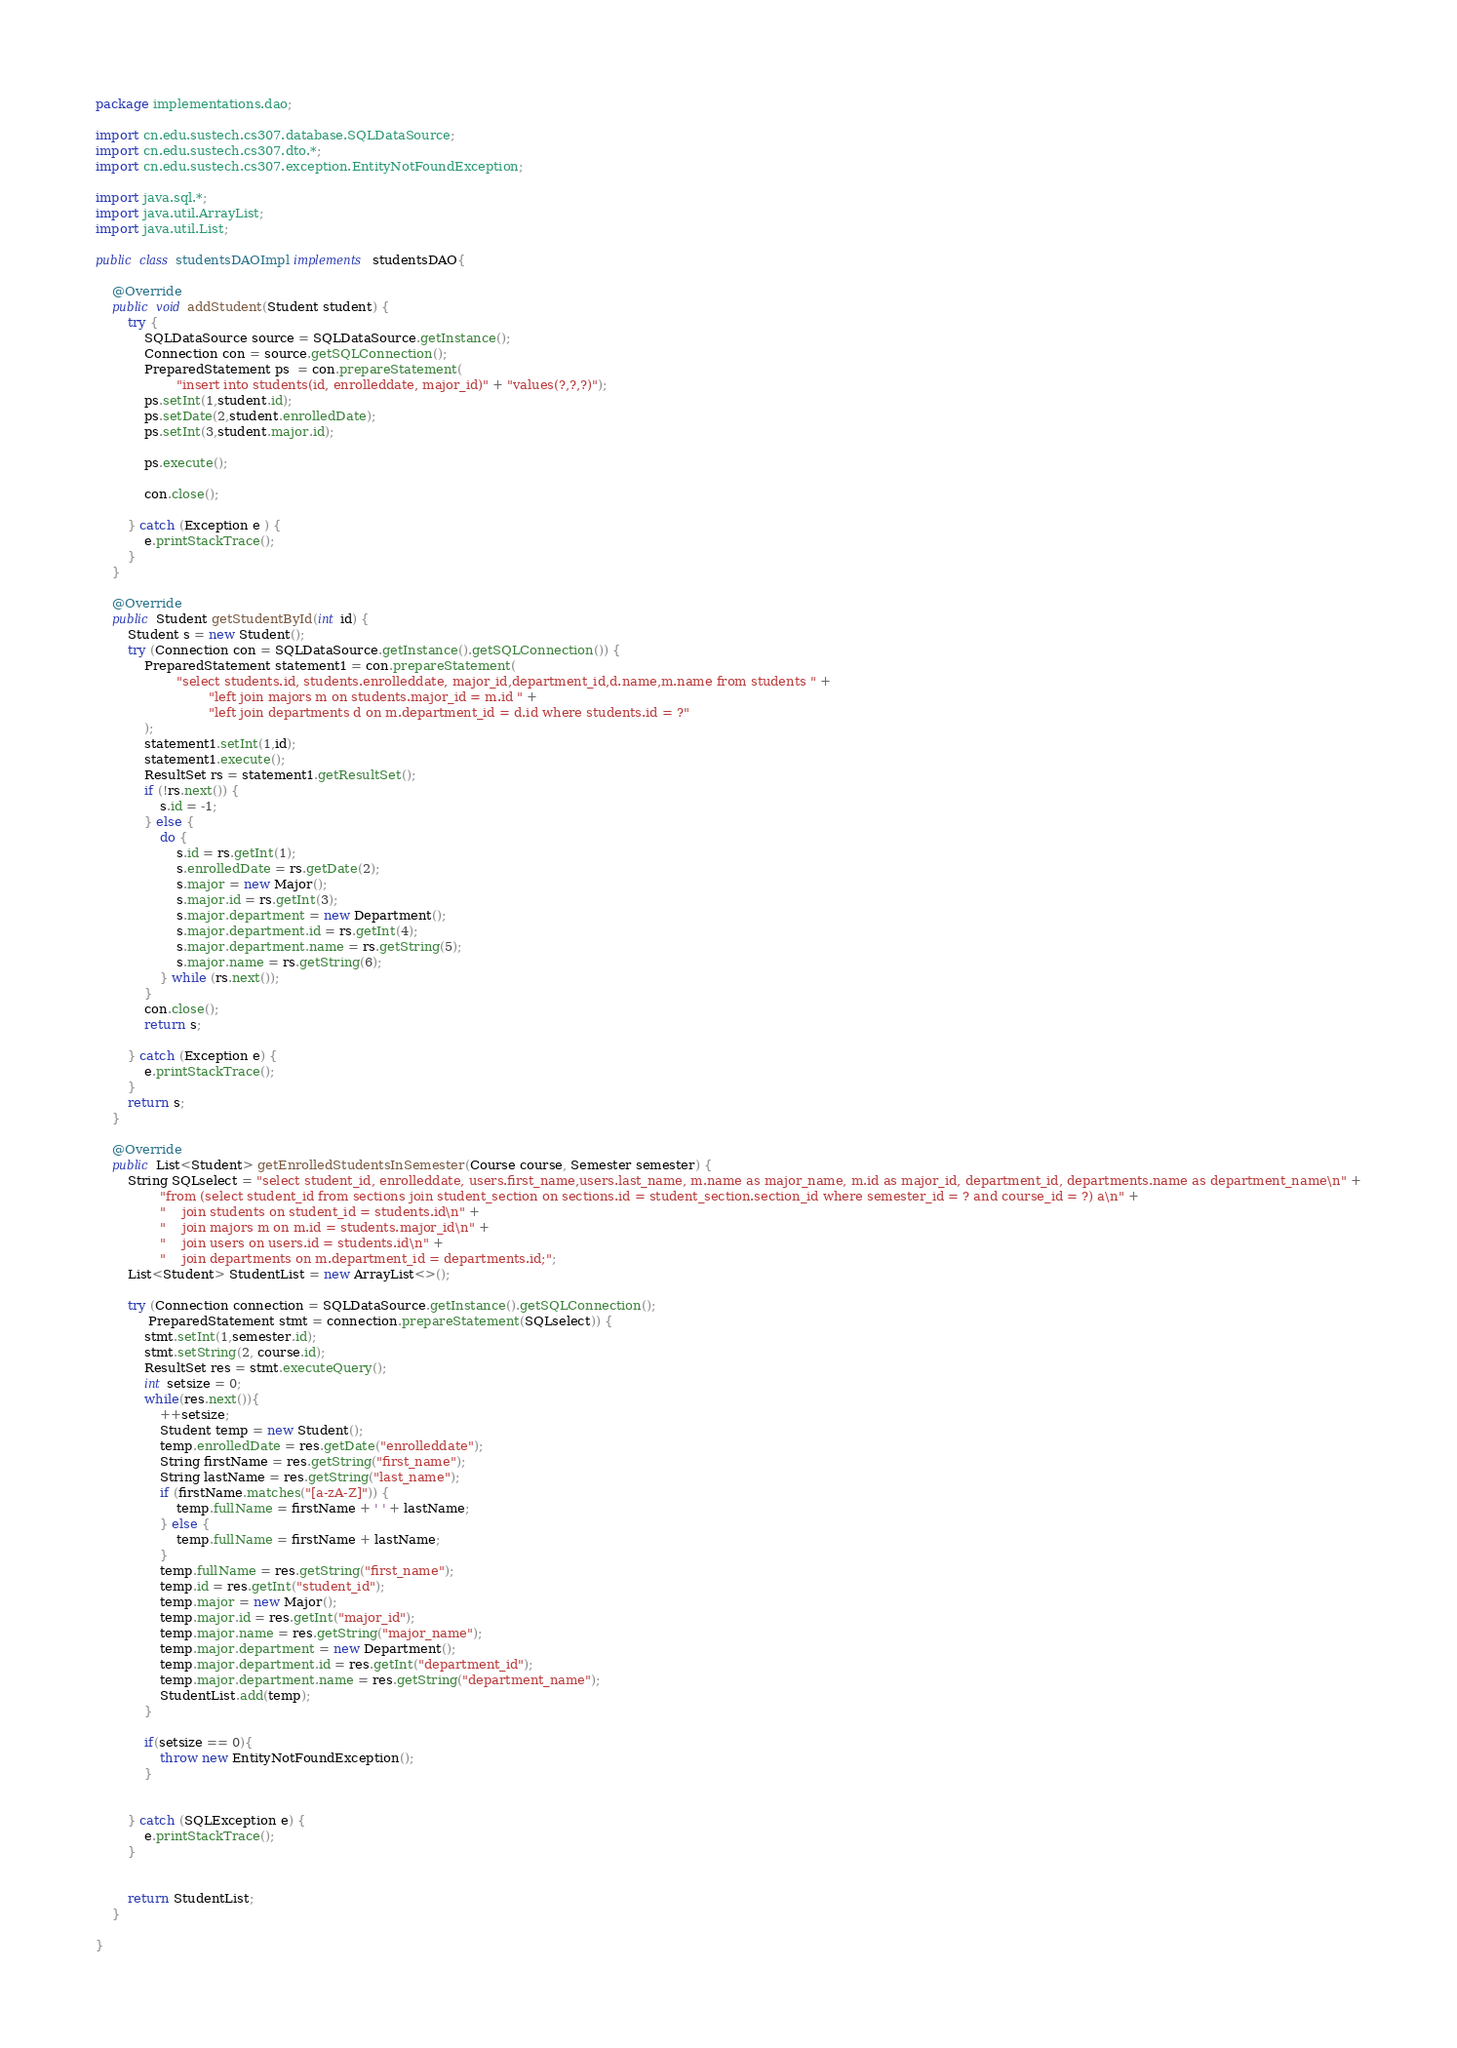Convert code to text. <code><loc_0><loc_0><loc_500><loc_500><_Java_>package implementations.dao;

import cn.edu.sustech.cs307.database.SQLDataSource;
import cn.edu.sustech.cs307.dto.*;
import cn.edu.sustech.cs307.exception.EntityNotFoundException;

import java.sql.*;
import java.util.ArrayList;
import java.util.List;

public class studentsDAOImpl implements studentsDAO{

    @Override
    public void addStudent(Student student) {
        try {
            SQLDataSource source = SQLDataSource.getInstance();
            Connection con = source.getSQLConnection();
            PreparedStatement ps  = con.prepareStatement(
                    "insert into students(id, enrolleddate, major_id)" + "values(?,?,?)");
            ps.setInt(1,student.id);
            ps.setDate(2,student.enrolledDate);
            ps.setInt(3,student.major.id);

            ps.execute();

            con.close();

        } catch (Exception e ) {
            e.printStackTrace();
        }
    }

    @Override
    public Student getStudentById(int id) {
        Student s = new Student();
        try (Connection con = SQLDataSource.getInstance().getSQLConnection()) {
            PreparedStatement statement1 = con.prepareStatement(
                    "select students.id, students.enrolleddate, major_id,department_id,d.name,m.name from students " +
                            "left join majors m on students.major_id = m.id " +
                            "left join departments d on m.department_id = d.id where students.id = ?"
            );
            statement1.setInt(1,id);
            statement1.execute();
            ResultSet rs = statement1.getResultSet();
            if (!rs.next()) {
                s.id = -1;
            } else {
                do {
                    s.id = rs.getInt(1);
                    s.enrolledDate = rs.getDate(2);
                    s.major = new Major();
                    s.major.id = rs.getInt(3);
                    s.major.department = new Department();
                    s.major.department.id = rs.getInt(4);
                    s.major.department.name = rs.getString(5);
                    s.major.name = rs.getString(6);
                } while (rs.next());
            }
            con.close();
            return s;

        } catch (Exception e) {
            e.printStackTrace();
        }
        return s;
    }

    @Override
    public List<Student> getEnrolledStudentsInSemester(Course course, Semester semester) {
        String SQLselect = "select student_id, enrolleddate, users.first_name,users.last_name, m.name as major_name, m.id as major_id, department_id, departments.name as department_name\n" +
                "from (select student_id from sections join student_section on sections.id = student_section.section_id where semester_id = ? and course_id = ?) a\n" +
                "    join students on student_id = students.id\n" +
                "    join majors m on m.id = students.major_id\n" +
                "    join users on users.id = students.id\n" +
                "    join departments on m.department_id = departments.id;";
        List<Student> StudentList = new ArrayList<>();

        try (Connection connection = SQLDataSource.getInstance().getSQLConnection();
             PreparedStatement stmt = connection.prepareStatement(SQLselect)) {
            stmt.setInt(1,semester.id);
            stmt.setString(2, course.id);
            ResultSet res = stmt.executeQuery();
            int setsize = 0;
            while(res.next()){
                ++setsize;
                Student temp = new Student();
                temp.enrolledDate = res.getDate("enrolleddate");
                String firstName = res.getString("first_name");
                String lastName = res.getString("last_name");
                if (firstName.matches("[a-zA-Z]")) {
                    temp.fullName = firstName + ' ' + lastName;
                } else {
                    temp.fullName = firstName + lastName;
                }
                temp.fullName = res.getString("first_name");
                temp.id = res.getInt("student_id");
                temp.major = new Major();
                temp.major.id = res.getInt("major_id");
                temp.major.name = res.getString("major_name");
                temp.major.department = new Department();
                temp.major.department.id = res.getInt("department_id");
                temp.major.department.name = res.getString("department_name");
                StudentList.add(temp);
            }

            if(setsize == 0){
                throw new EntityNotFoundException();
            }


        } catch (SQLException e) {
            e.printStackTrace();
        }


        return StudentList;
    }

}
</code> 